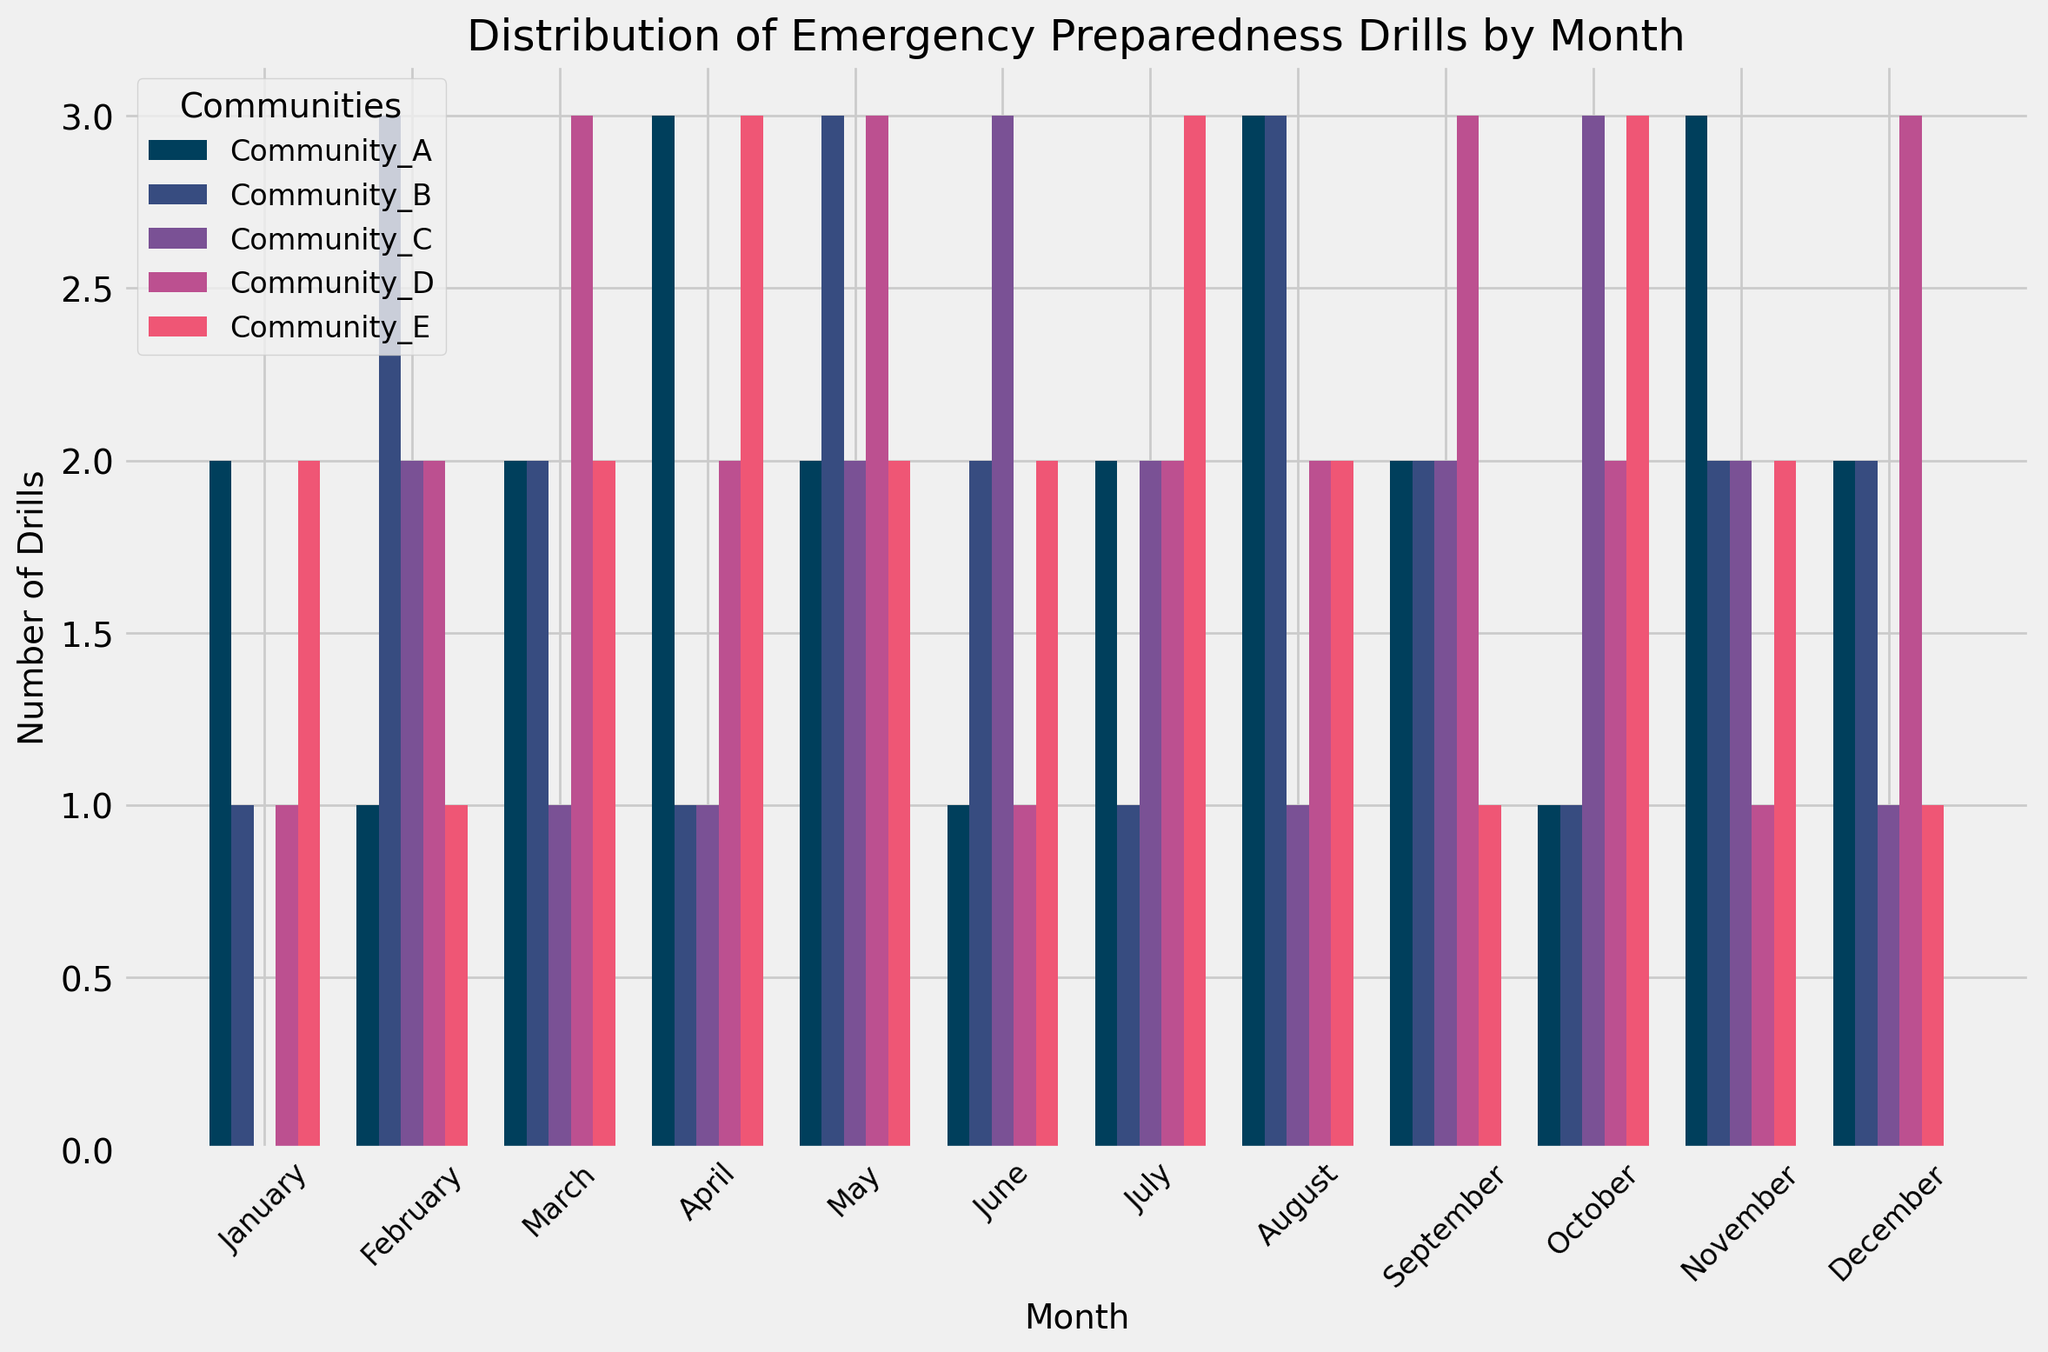Which community conducted the most drills in March? Look at the bars for March across all communities. Identify the highest bar. Community_D has the highest bar with 3 drills.
Answer: Community_D Which month had the highest total number of drills across all communities? Sum the number of drills for each month across all communities. February, April, and May each have a total of 11 drills.
Answer: February, April, May Which community had the least number of drills in July? Look at the bars for July across all communities. Identify the shortest bar. Community_B has the shortest bar with 1 drill.
Answer: Community_B What is the average number of drills conducted by Community_C over the year? Sum the drills for Community_C across all months and divide by 12. (0 + 2 + 1 + 1 + 2 + 3 + 2 + 1 + 2 + 3 + 2 + 1) = 20, average is 20/12 ≈ 1.67
Answer: 1.67 Did any community conduct the same number of drills in consecutive months? Look for consecutive months with bars of the same height for any community. Community_E conducted 2 drills in January and February, and again in May and June. Community_C conducted 1 drill in April and March, and again in August and December.
Answer: Yes Which month had the highest number of drills in Community_B? Look for the highest bar corresponding to Community_B. February and August have the highest bars with 3 drills each.
Answer: February, August How many more drills did Community_A conduct in April compared to June? Subtract the number of drills in June from the number in April for Community_A. 3 - 1 = 2
Answer: 2 What is the combined total number of drills conducted by all communities in the first quarter of the year (January to March)? Sum the drills for January, February, and March across all communities. January: 6, February: 9, March: 10. Total is 6 + 9 + 10 = 25
Answer: 25 Which community had the greatest variation in drill frequencies over the year? Observe the range between the highest and lowest number of drills for each community. Community_D has the greatest variation with a range from 1 to 3 drills.
Answer: Community_D In which month did Community_E conduct the most drills? Look for the highest bar for Community_E. April and October have the highest bars with 3 drills each.
Answer: April, October 